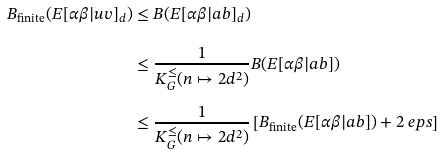Convert formula to latex. <formula><loc_0><loc_0><loc_500><loc_500>B _ { \text {finite} } ( E [ \alpha \beta | u v ] _ { d } ) & \leq B ( E [ \alpha \beta | a b ] _ { d } ) \\ & \leq \frac { 1 } { K ^ { \leq } _ { G } ( n \mapsto 2 d ^ { 2 } ) } B ( E [ \alpha \beta | a b ] ) \\ & \leq \frac { 1 } { K ^ { \leq } _ { G } ( n \mapsto 2 d ^ { 2 } ) } \left [ B _ { \text {finite} } ( E [ \alpha \beta | a b ] ) + 2 \ e p s \right ]</formula> 